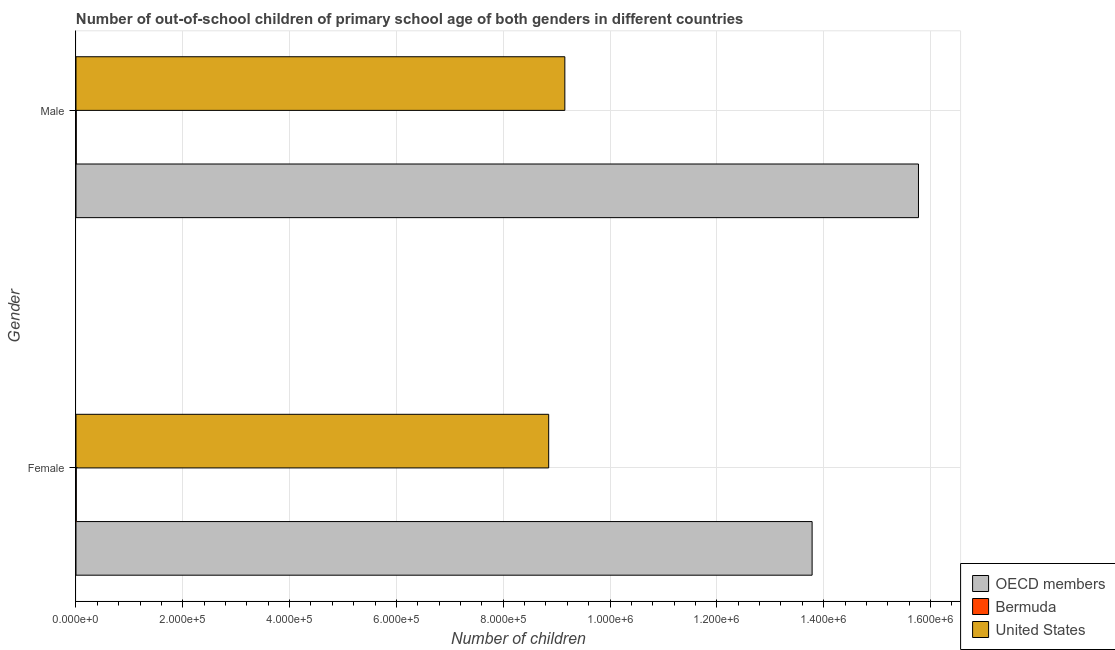Are the number of bars per tick equal to the number of legend labels?
Your answer should be very brief. Yes. How many bars are there on the 1st tick from the top?
Make the answer very short. 3. How many bars are there on the 2nd tick from the bottom?
Your answer should be very brief. 3. What is the label of the 1st group of bars from the top?
Offer a terse response. Male. What is the number of male out-of-school students in Bermuda?
Provide a succinct answer. 359. Across all countries, what is the maximum number of female out-of-school students?
Ensure brevity in your answer.  1.38e+06. Across all countries, what is the minimum number of female out-of-school students?
Ensure brevity in your answer.  438. In which country was the number of female out-of-school students maximum?
Ensure brevity in your answer.  OECD members. In which country was the number of female out-of-school students minimum?
Your answer should be very brief. Bermuda. What is the total number of male out-of-school students in the graph?
Offer a terse response. 2.49e+06. What is the difference between the number of male out-of-school students in OECD members and that in Bermuda?
Provide a short and direct response. 1.58e+06. What is the difference between the number of female out-of-school students in United States and the number of male out-of-school students in Bermuda?
Offer a terse response. 8.85e+05. What is the average number of female out-of-school students per country?
Your response must be concise. 7.55e+05. What is the difference between the number of female out-of-school students and number of male out-of-school students in Bermuda?
Your response must be concise. 79. What is the ratio of the number of male out-of-school students in OECD members to that in Bermuda?
Your response must be concise. 4394.02. In how many countries, is the number of female out-of-school students greater than the average number of female out-of-school students taken over all countries?
Ensure brevity in your answer.  2. What does the 2nd bar from the top in Male represents?
Give a very brief answer. Bermuda. What does the 1st bar from the bottom in Female represents?
Ensure brevity in your answer.  OECD members. What is the difference between two consecutive major ticks on the X-axis?
Keep it short and to the point. 2.00e+05. Are the values on the major ticks of X-axis written in scientific E-notation?
Your response must be concise. Yes. Does the graph contain any zero values?
Your response must be concise. No. Where does the legend appear in the graph?
Your response must be concise. Bottom right. How many legend labels are there?
Keep it short and to the point. 3. What is the title of the graph?
Your answer should be compact. Number of out-of-school children of primary school age of both genders in different countries. Does "Guam" appear as one of the legend labels in the graph?
Offer a terse response. No. What is the label or title of the X-axis?
Give a very brief answer. Number of children. What is the label or title of the Y-axis?
Make the answer very short. Gender. What is the Number of children of OECD members in Female?
Provide a succinct answer. 1.38e+06. What is the Number of children of Bermuda in Female?
Keep it short and to the point. 438. What is the Number of children in United States in Female?
Your response must be concise. 8.85e+05. What is the Number of children of OECD members in Male?
Provide a short and direct response. 1.58e+06. What is the Number of children in Bermuda in Male?
Your response must be concise. 359. What is the Number of children of United States in Male?
Offer a terse response. 9.15e+05. Across all Gender, what is the maximum Number of children in OECD members?
Offer a very short reply. 1.58e+06. Across all Gender, what is the maximum Number of children in Bermuda?
Provide a succinct answer. 438. Across all Gender, what is the maximum Number of children of United States?
Your response must be concise. 9.15e+05. Across all Gender, what is the minimum Number of children of OECD members?
Provide a succinct answer. 1.38e+06. Across all Gender, what is the minimum Number of children in Bermuda?
Keep it short and to the point. 359. Across all Gender, what is the minimum Number of children in United States?
Provide a succinct answer. 8.85e+05. What is the total Number of children of OECD members in the graph?
Provide a succinct answer. 2.96e+06. What is the total Number of children in Bermuda in the graph?
Your answer should be compact. 797. What is the total Number of children of United States in the graph?
Give a very brief answer. 1.80e+06. What is the difference between the Number of children of OECD members in Female and that in Male?
Your response must be concise. -1.99e+05. What is the difference between the Number of children in Bermuda in Female and that in Male?
Your response must be concise. 79. What is the difference between the Number of children of United States in Female and that in Male?
Keep it short and to the point. -3.02e+04. What is the difference between the Number of children in OECD members in Female and the Number of children in Bermuda in Male?
Your response must be concise. 1.38e+06. What is the difference between the Number of children in OECD members in Female and the Number of children in United States in Male?
Your answer should be very brief. 4.63e+05. What is the difference between the Number of children in Bermuda in Female and the Number of children in United States in Male?
Give a very brief answer. -9.15e+05. What is the average Number of children of OECD members per Gender?
Offer a very short reply. 1.48e+06. What is the average Number of children of Bermuda per Gender?
Your answer should be compact. 398.5. What is the average Number of children in United States per Gender?
Your response must be concise. 9.00e+05. What is the difference between the Number of children of OECD members and Number of children of Bermuda in Female?
Your answer should be compact. 1.38e+06. What is the difference between the Number of children in OECD members and Number of children in United States in Female?
Your answer should be compact. 4.93e+05. What is the difference between the Number of children in Bermuda and Number of children in United States in Female?
Ensure brevity in your answer.  -8.85e+05. What is the difference between the Number of children of OECD members and Number of children of Bermuda in Male?
Offer a very short reply. 1.58e+06. What is the difference between the Number of children of OECD members and Number of children of United States in Male?
Give a very brief answer. 6.62e+05. What is the difference between the Number of children in Bermuda and Number of children in United States in Male?
Keep it short and to the point. -9.15e+05. What is the ratio of the Number of children of OECD members in Female to that in Male?
Keep it short and to the point. 0.87. What is the ratio of the Number of children of Bermuda in Female to that in Male?
Make the answer very short. 1.22. What is the difference between the highest and the second highest Number of children of OECD members?
Offer a very short reply. 1.99e+05. What is the difference between the highest and the second highest Number of children of Bermuda?
Your response must be concise. 79. What is the difference between the highest and the second highest Number of children in United States?
Your response must be concise. 3.02e+04. What is the difference between the highest and the lowest Number of children of OECD members?
Offer a very short reply. 1.99e+05. What is the difference between the highest and the lowest Number of children in Bermuda?
Give a very brief answer. 79. What is the difference between the highest and the lowest Number of children in United States?
Provide a succinct answer. 3.02e+04. 